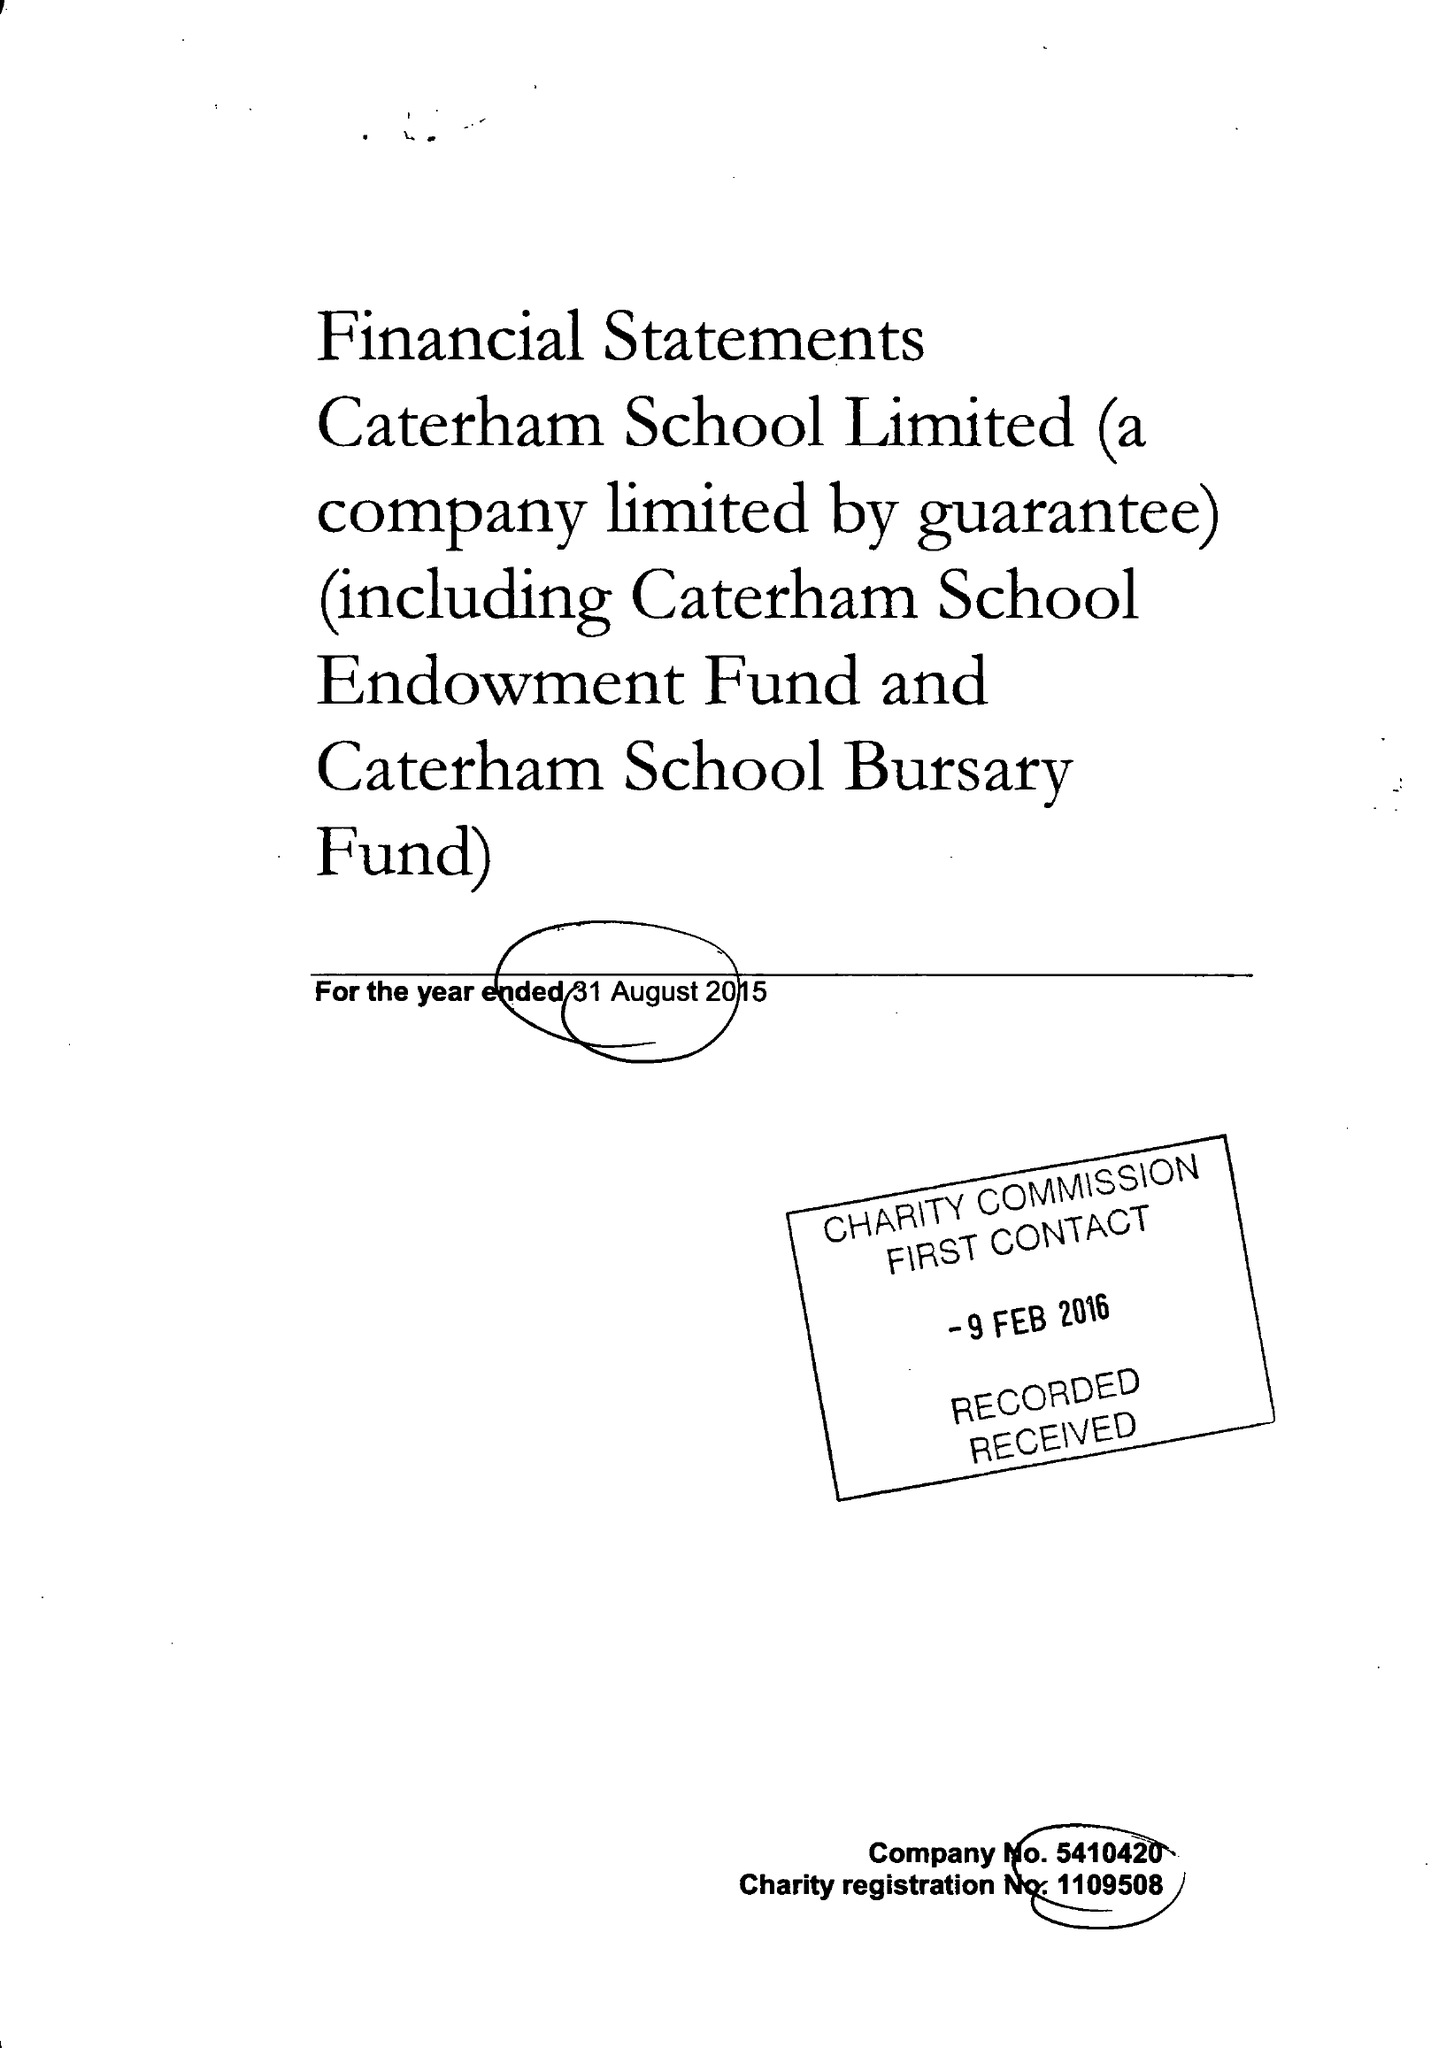What is the value for the spending_annually_in_british_pounds?
Answer the question using a single word or phrase. 17028000.00 